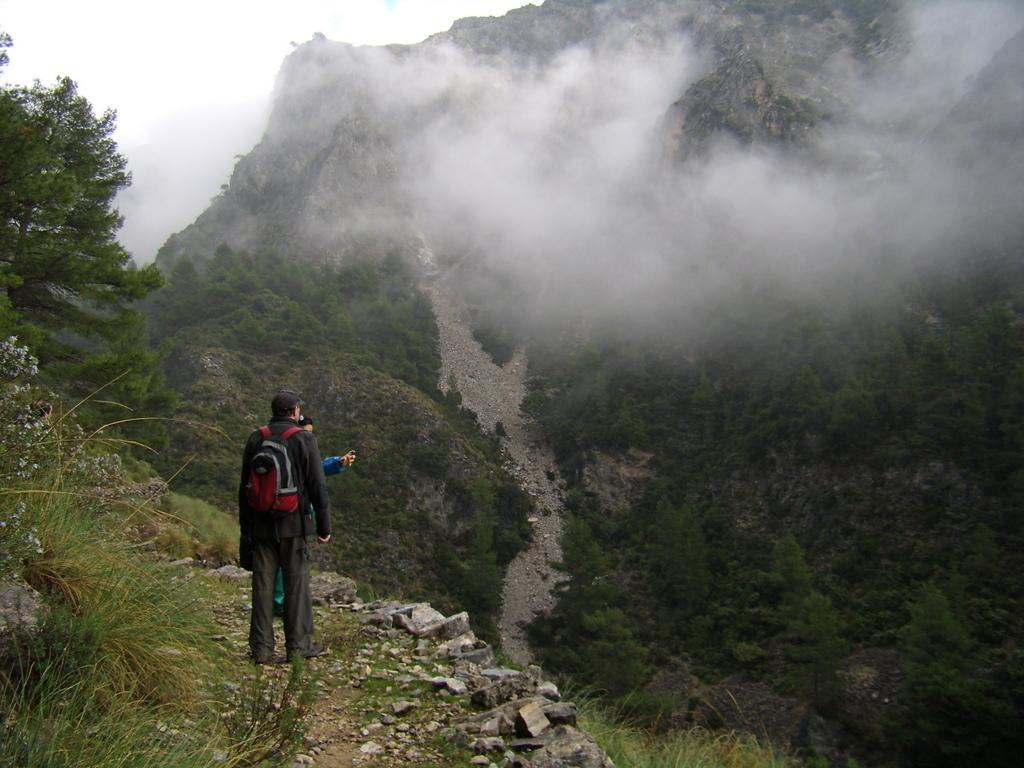What type of landscape feature is present in the image? There is a hill in the image. What can be seen growing on the hill? There are trees in the image. What is the source of the smoke visible in the image? The source of the smoke is not specified in the image. How many people are present in the image? There are people standing in the image. What is the man wearing on his back? A man is wearing a backpack on his back. What is the man wearing on his head? A man is wearing a cap on his head. What type of natural feature can be seen on the hill? There are rocks in the image. What type of dog is sitting next to the man wearing the cap? There is no dog present in the image. What type of trade is being conducted between the people in the image? There is no indication of any trade being conducted in the image. 